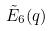Convert formula to latex. <formula><loc_0><loc_0><loc_500><loc_500>\tilde { E } _ { 6 } ( q )</formula> 